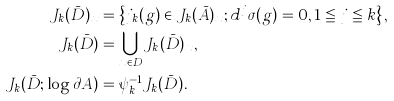<formula> <loc_0><loc_0><loc_500><loc_500>J _ { k } ( \bar { D } ) _ { x } & = \left \{ j _ { k } ( g ) \in J _ { k } ( \bar { A } ) _ { x } ; d ^ { j } \sigma ( g ) = 0 , 1 \leqq j \leqq k \right \} , \\ J _ { k } ( \bar { D } ) & = \bigcup _ { x \in D } J _ { k } ( \bar { D } ) _ { x } , \\ J _ { k } ( \bar { D } ; \log \partial A ) & = \psi _ { k } ^ { - 1 } J _ { k } ( \bar { D } ) .</formula> 